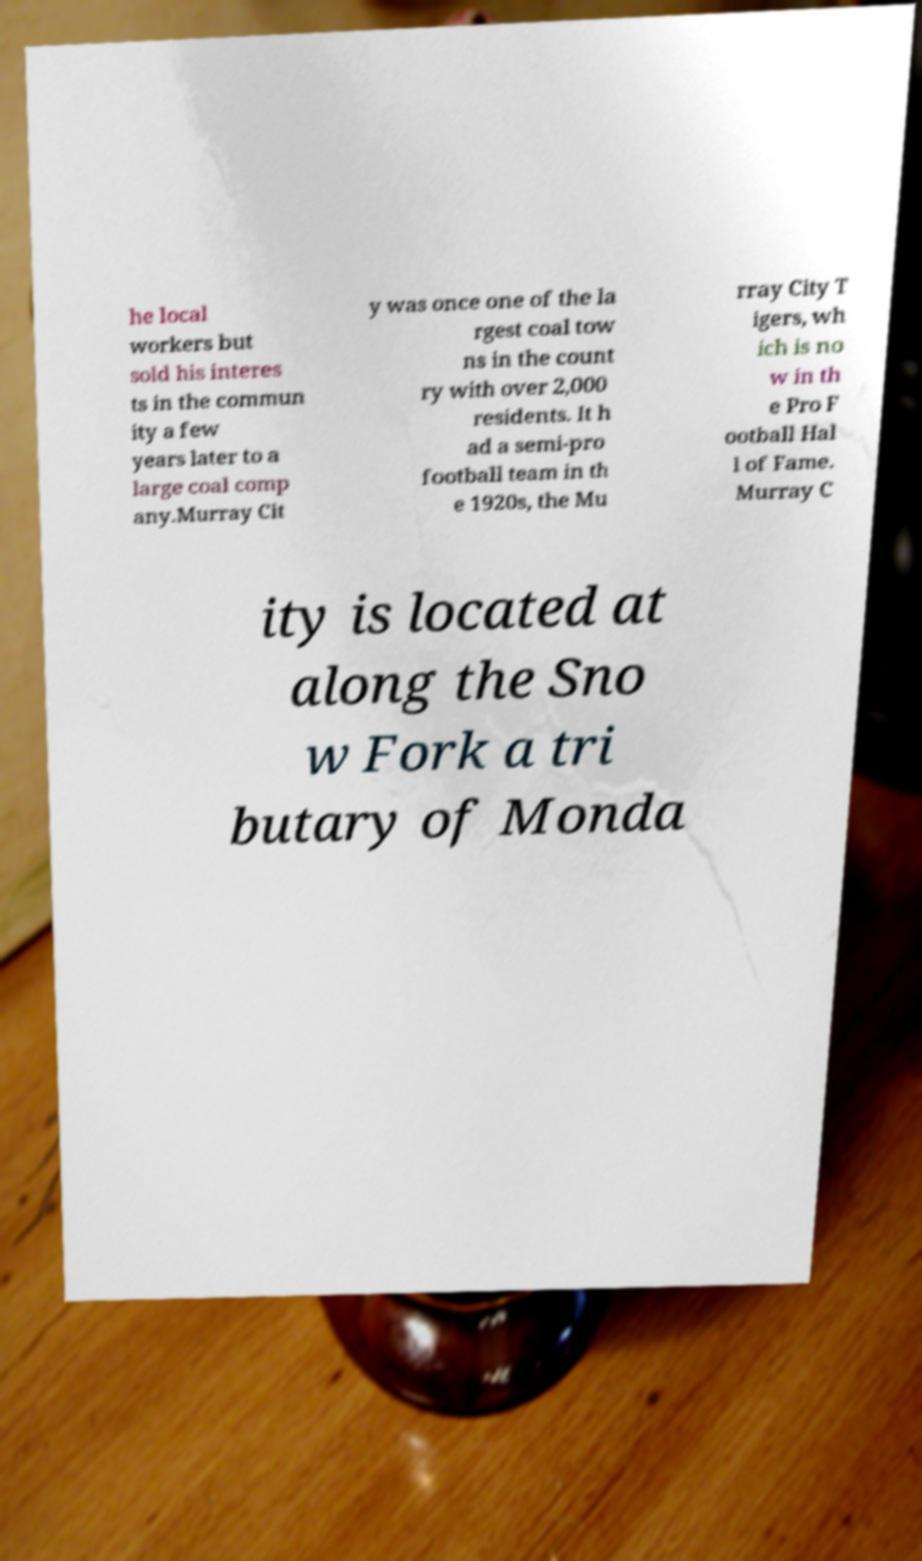What messages or text are displayed in this image? I need them in a readable, typed format. he local workers but sold his interes ts in the commun ity a few years later to a large coal comp any.Murray Cit y was once one of the la rgest coal tow ns in the count ry with over 2,000 residents. It h ad a semi-pro football team in th e 1920s, the Mu rray City T igers, wh ich is no w in th e Pro F ootball Hal l of Fame. Murray C ity is located at along the Sno w Fork a tri butary of Monda 